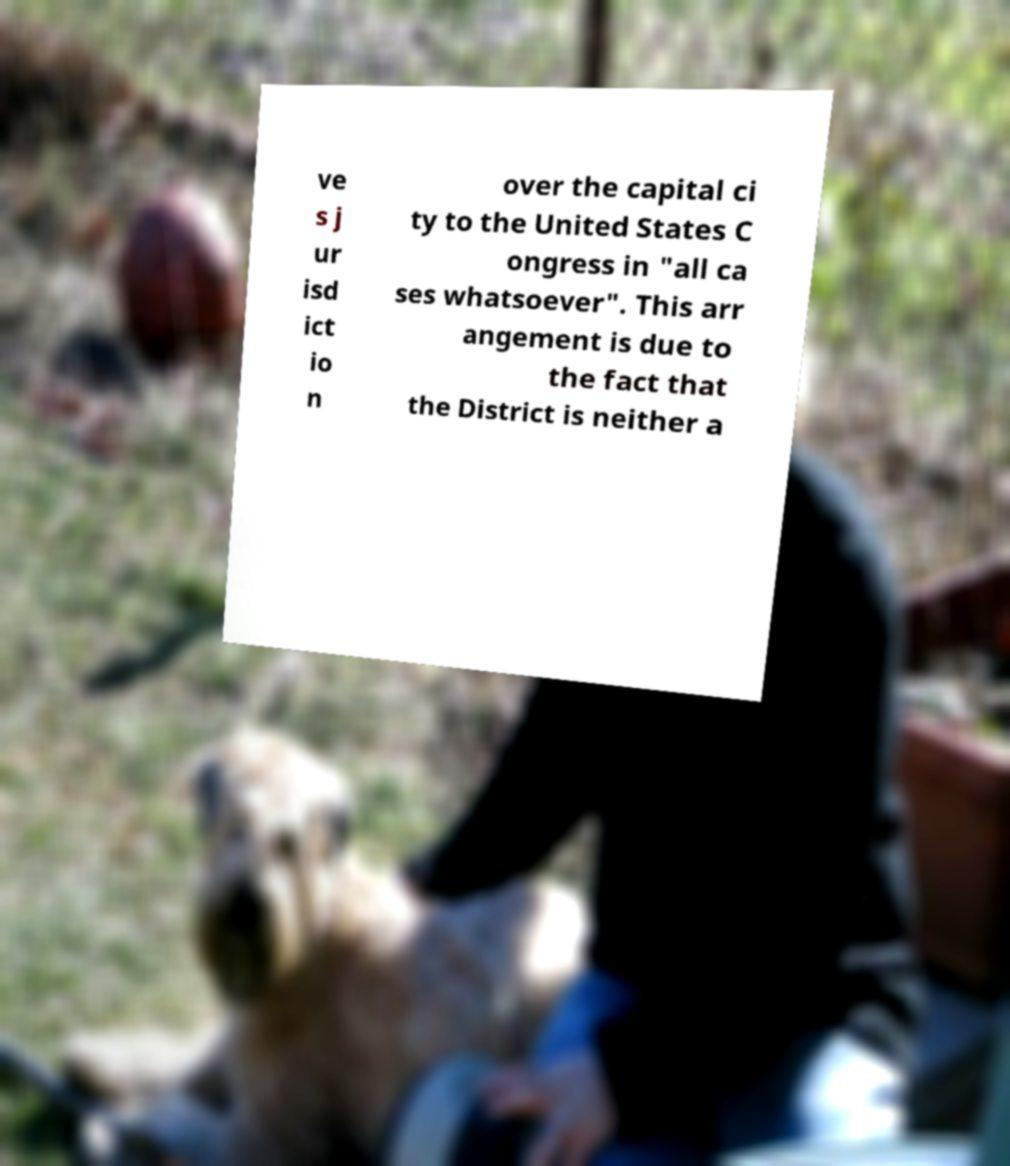Could you assist in decoding the text presented in this image and type it out clearly? ve s j ur isd ict io n over the capital ci ty to the United States C ongress in "all ca ses whatsoever". This arr angement is due to the fact that the District is neither a 